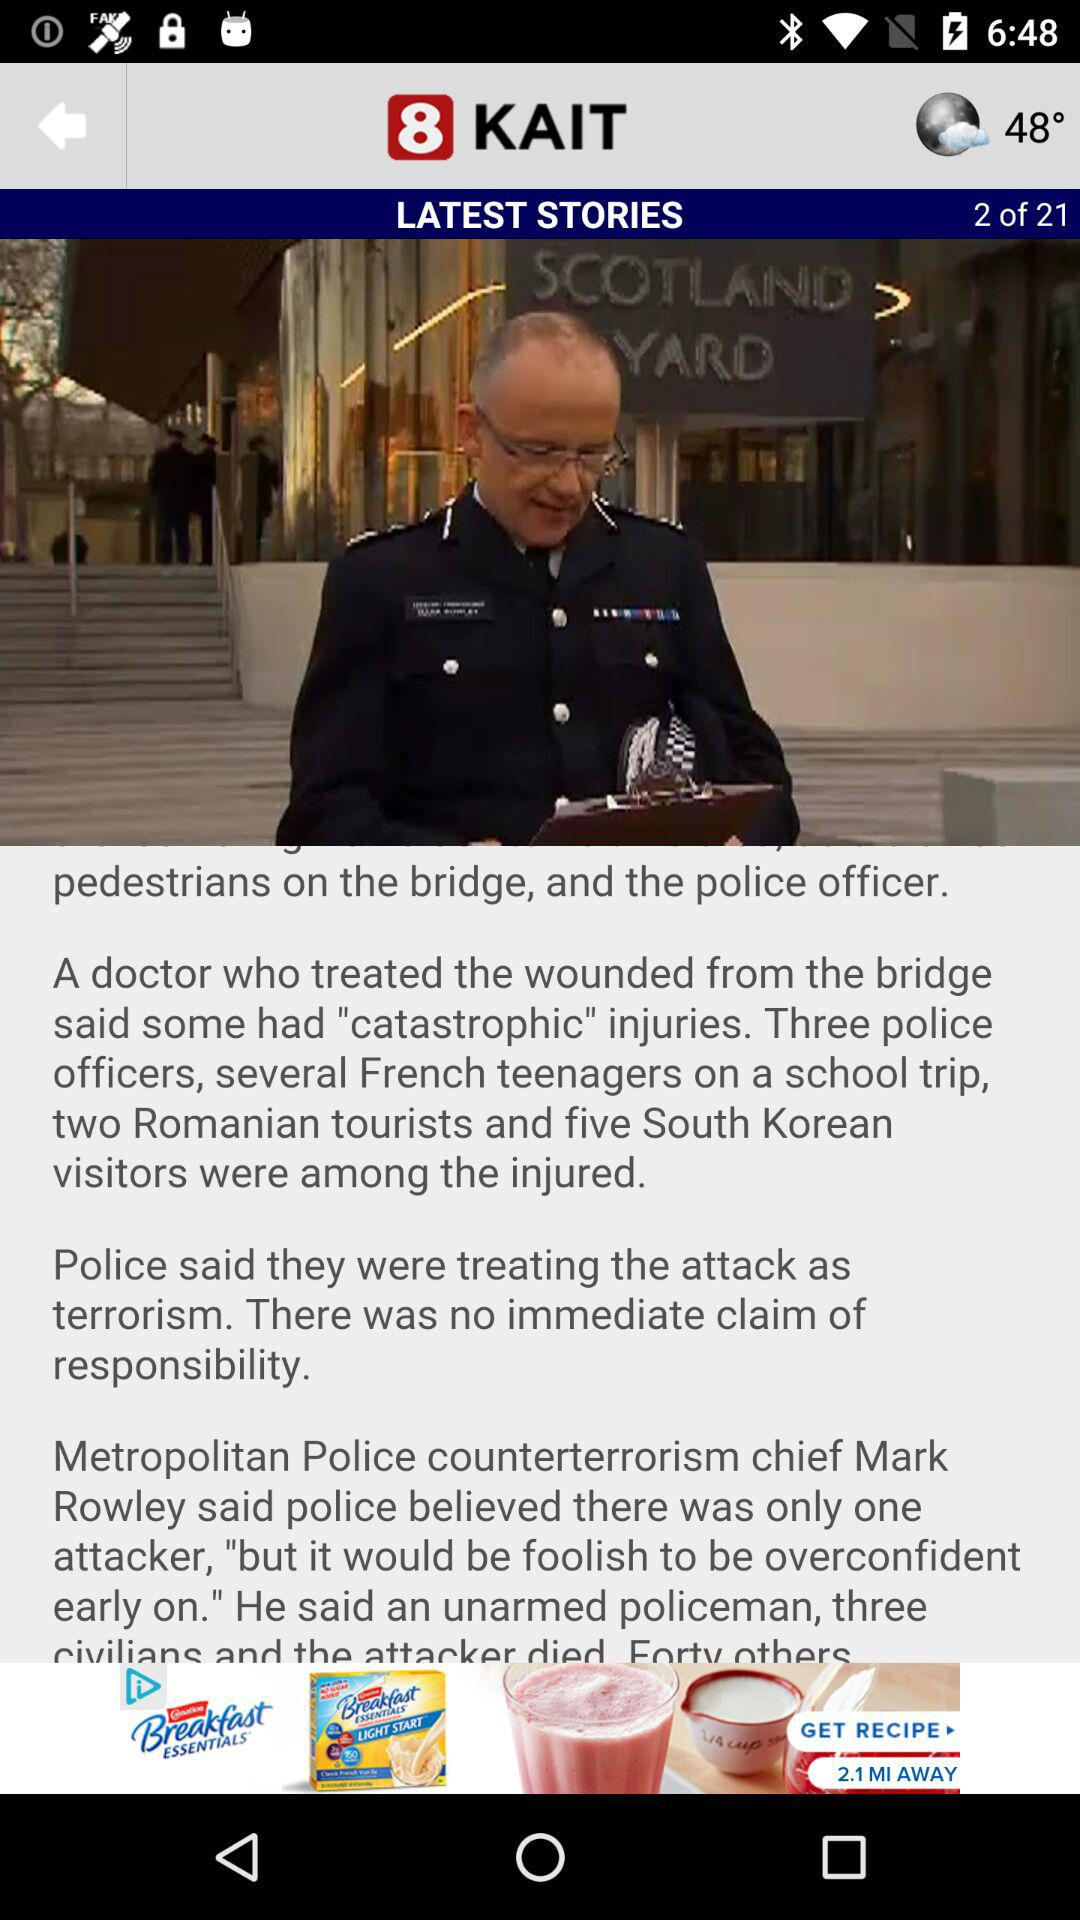Which article number of the latest stories is currently shown on the screen? The currently shown article number is 2. 